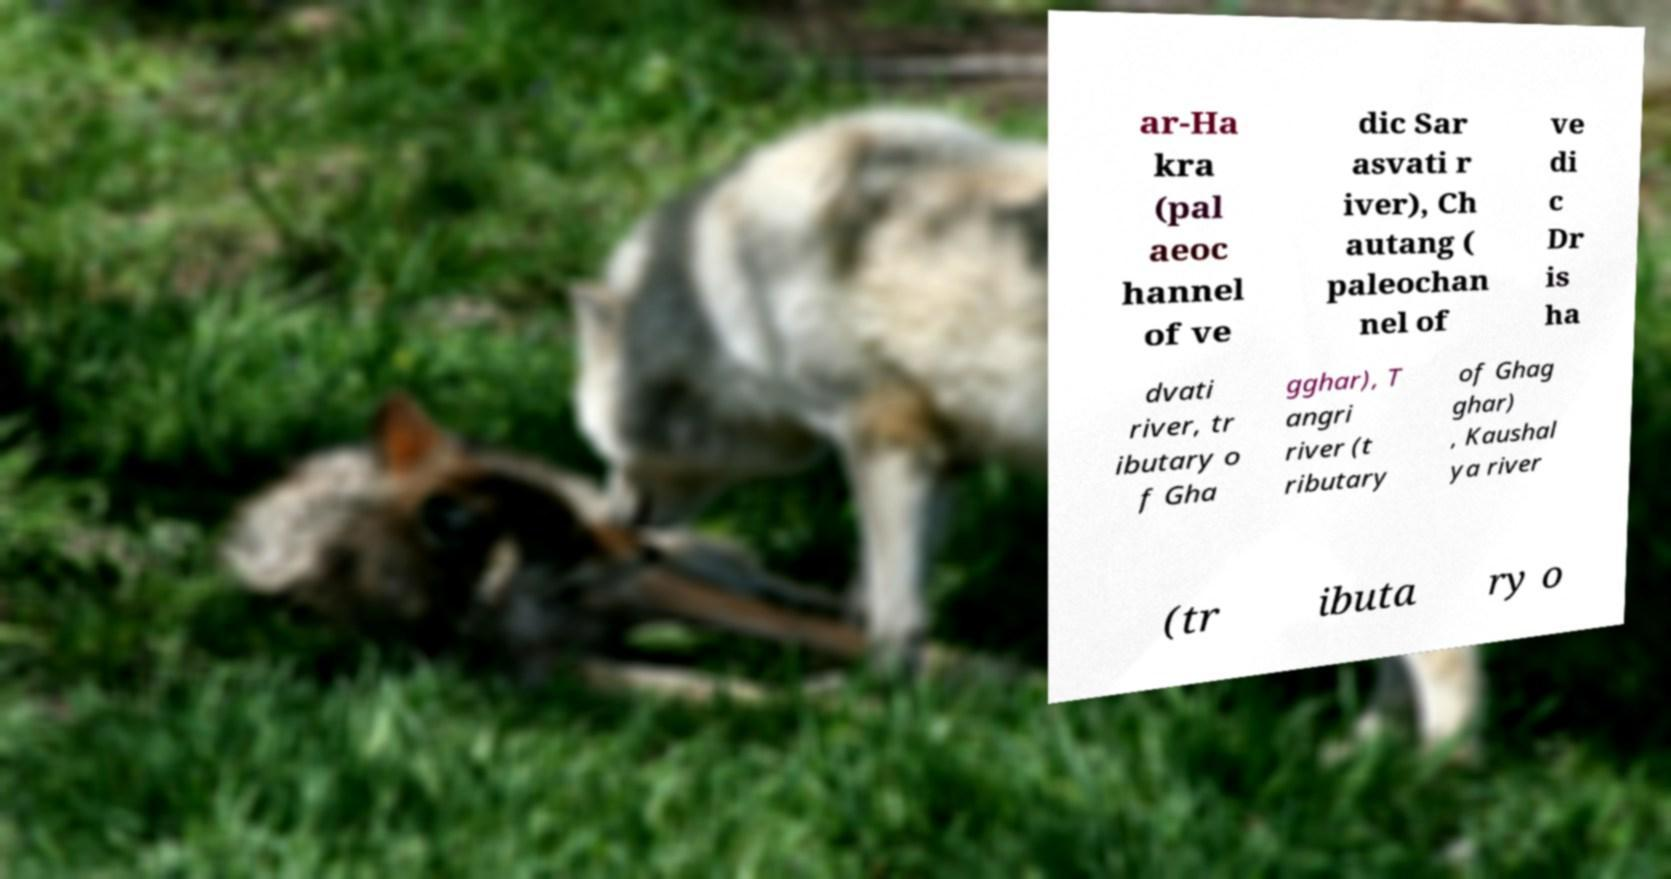Could you extract and type out the text from this image? ar-Ha kra (pal aeoc hannel of ve dic Sar asvati r iver), Ch autang ( paleochan nel of ve di c Dr is ha dvati river, tr ibutary o f Gha gghar), T angri river (t ributary of Ghag ghar) , Kaushal ya river (tr ibuta ry o 